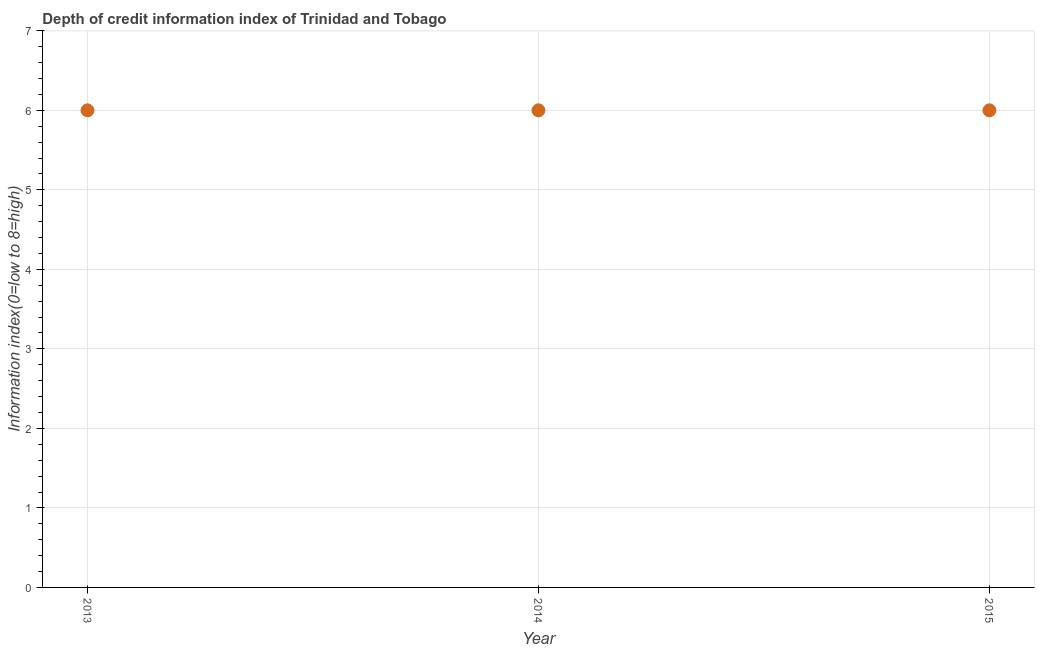What is the sum of the depth of credit information index?
Your response must be concise. 18. What is the median depth of credit information index?
Give a very brief answer. 6. In how many years, is the depth of credit information index greater than 0.8 ?
Your answer should be very brief. 3. Do a majority of the years between 2014 and 2013 (inclusive) have depth of credit information index greater than 5.8 ?
Give a very brief answer. No. What is the ratio of the depth of credit information index in 2014 to that in 2015?
Offer a very short reply. 1. Is the depth of credit information index in 2013 less than that in 2015?
Offer a very short reply. No. Is the difference between the depth of credit information index in 2013 and 2014 greater than the difference between any two years?
Provide a short and direct response. Yes. In how many years, is the depth of credit information index greater than the average depth of credit information index taken over all years?
Your answer should be compact. 0. Does the depth of credit information index monotonically increase over the years?
Your answer should be compact. No. How many dotlines are there?
Give a very brief answer. 1. How many years are there in the graph?
Keep it short and to the point. 3. What is the difference between two consecutive major ticks on the Y-axis?
Make the answer very short. 1. Does the graph contain grids?
Ensure brevity in your answer.  Yes. What is the title of the graph?
Provide a succinct answer. Depth of credit information index of Trinidad and Tobago. What is the label or title of the X-axis?
Keep it short and to the point. Year. What is the label or title of the Y-axis?
Your response must be concise. Information index(0=low to 8=high). What is the Information index(0=low to 8=high) in 2014?
Provide a short and direct response. 6. What is the Information index(0=low to 8=high) in 2015?
Keep it short and to the point. 6. What is the difference between the Information index(0=low to 8=high) in 2014 and 2015?
Offer a very short reply. 0. What is the ratio of the Information index(0=low to 8=high) in 2013 to that in 2015?
Provide a short and direct response. 1. What is the ratio of the Information index(0=low to 8=high) in 2014 to that in 2015?
Give a very brief answer. 1. 